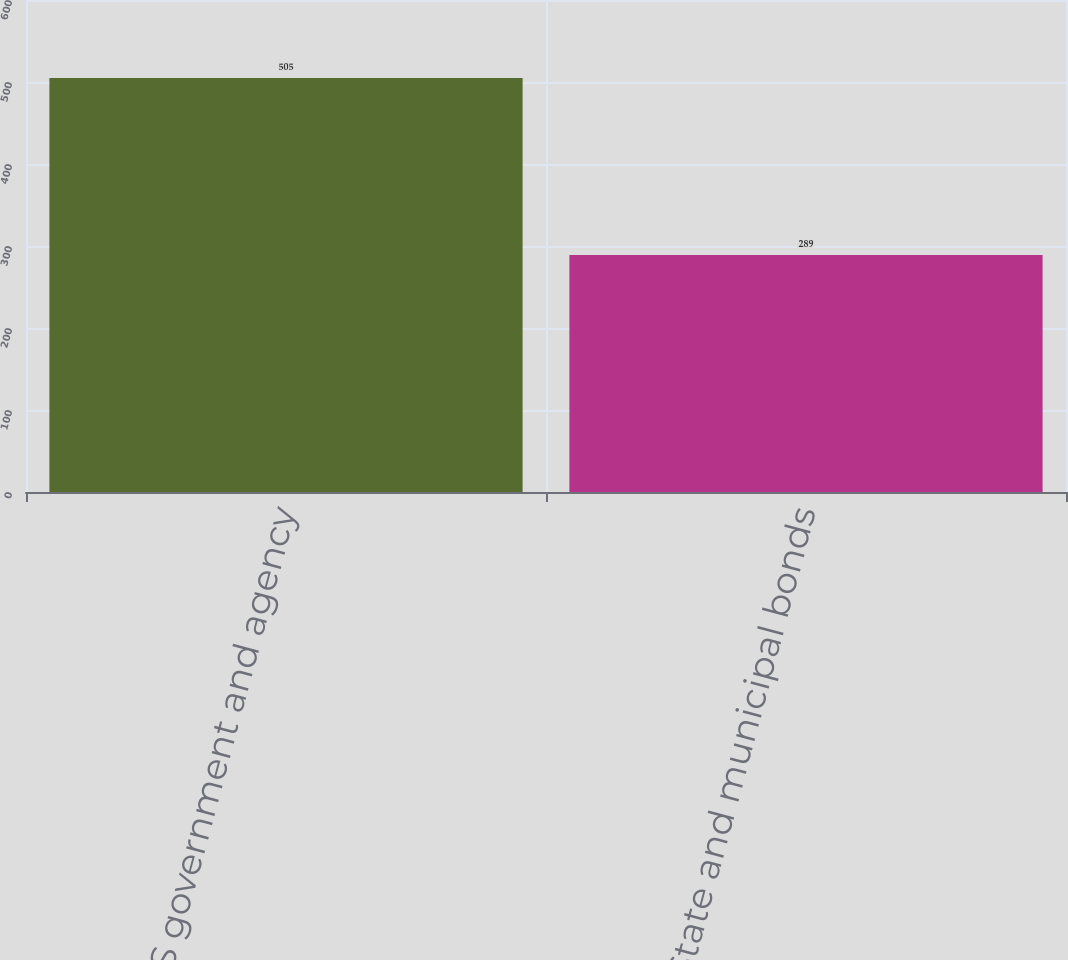Convert chart to OTSL. <chart><loc_0><loc_0><loc_500><loc_500><bar_chart><fcel>US government and agency<fcel>State and municipal bonds<nl><fcel>505<fcel>289<nl></chart> 